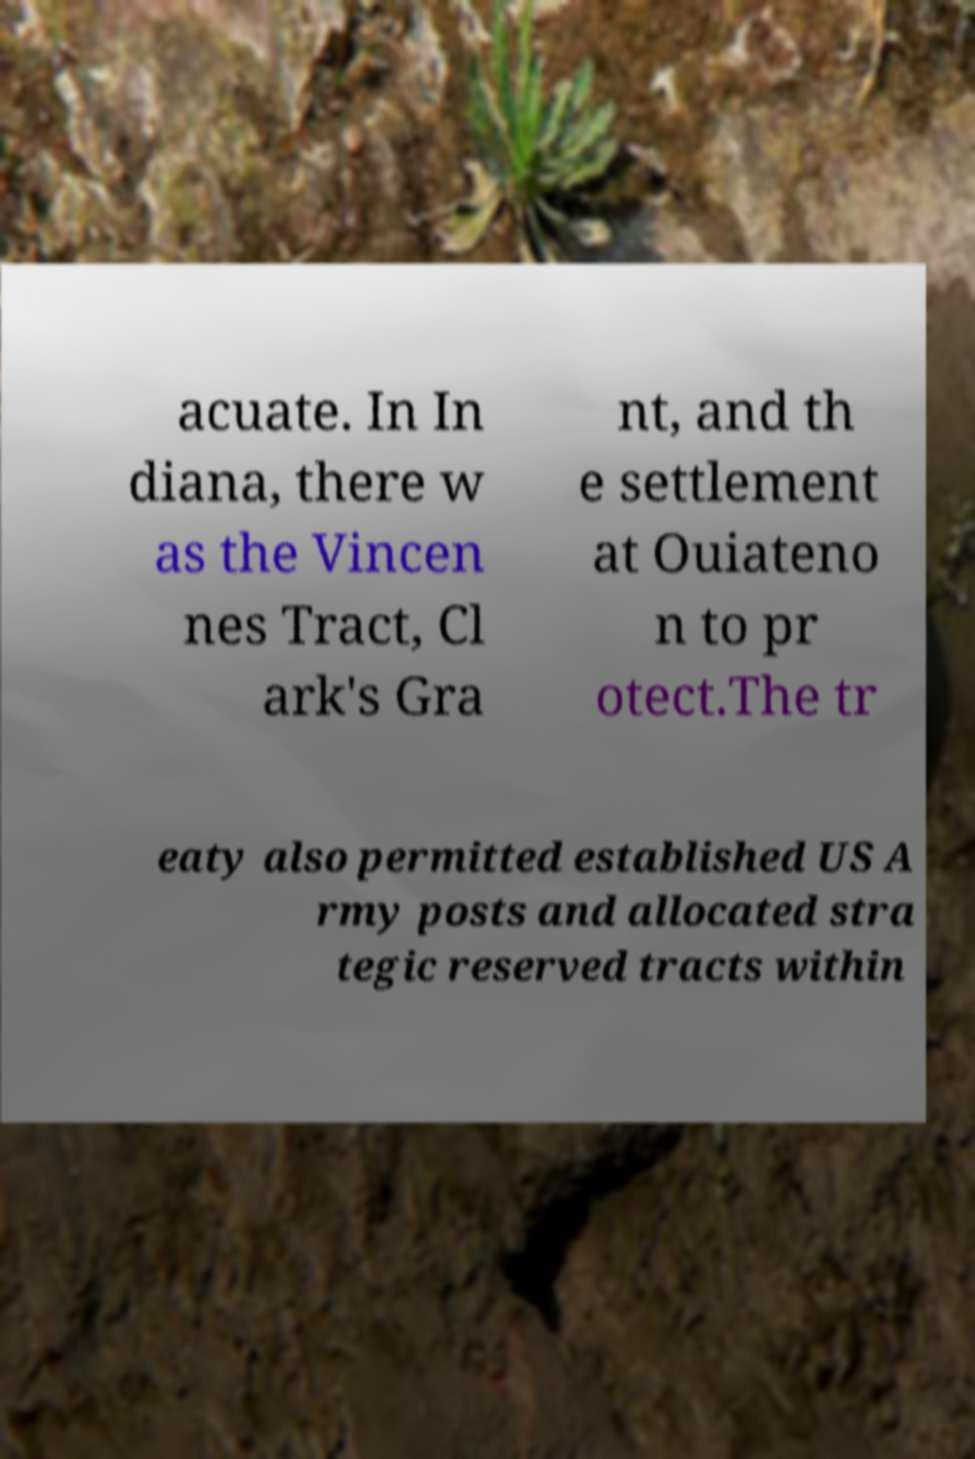Can you read and provide the text displayed in the image?This photo seems to have some interesting text. Can you extract and type it out for me? acuate. In In diana, there w as the Vincen nes Tract, Cl ark's Gra nt, and th e settlement at Ouiateno n to pr otect.The tr eaty also permitted established US A rmy posts and allocated stra tegic reserved tracts within 